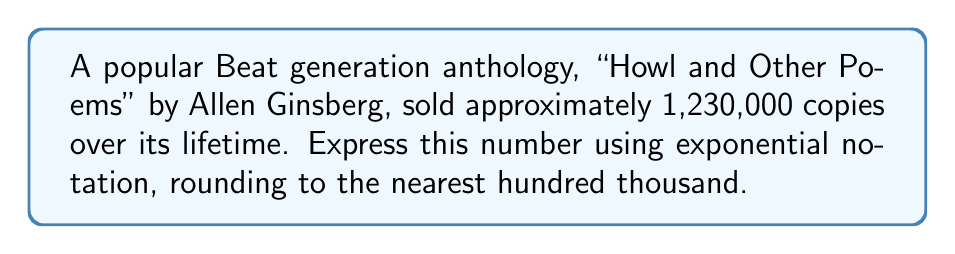Give your solution to this math problem. To express 1,230,000 in exponential notation and round to the nearest hundred thousand, we follow these steps:

1. Round 1,230,000 to the nearest hundred thousand:
   $1,230,000 \approx 1,200,000$

2. Express 1,200,000 as a product of a number between 1 and 10, and a power of 10:
   $1,200,000 = 1.2 \times 1,000,000$

3. Write 1,000,000 as a power of 10:
   $1,000,000 = 10^6$

4. Combine the results from steps 2 and 3:
   $1,200,000 = 1.2 \times 10^6$

Therefore, the estimated number of copies sold, expressed in exponential notation and rounded to the nearest hundred thousand, is $1.2 \times 10^6$.
Answer: $1.2 \times 10^6$ 